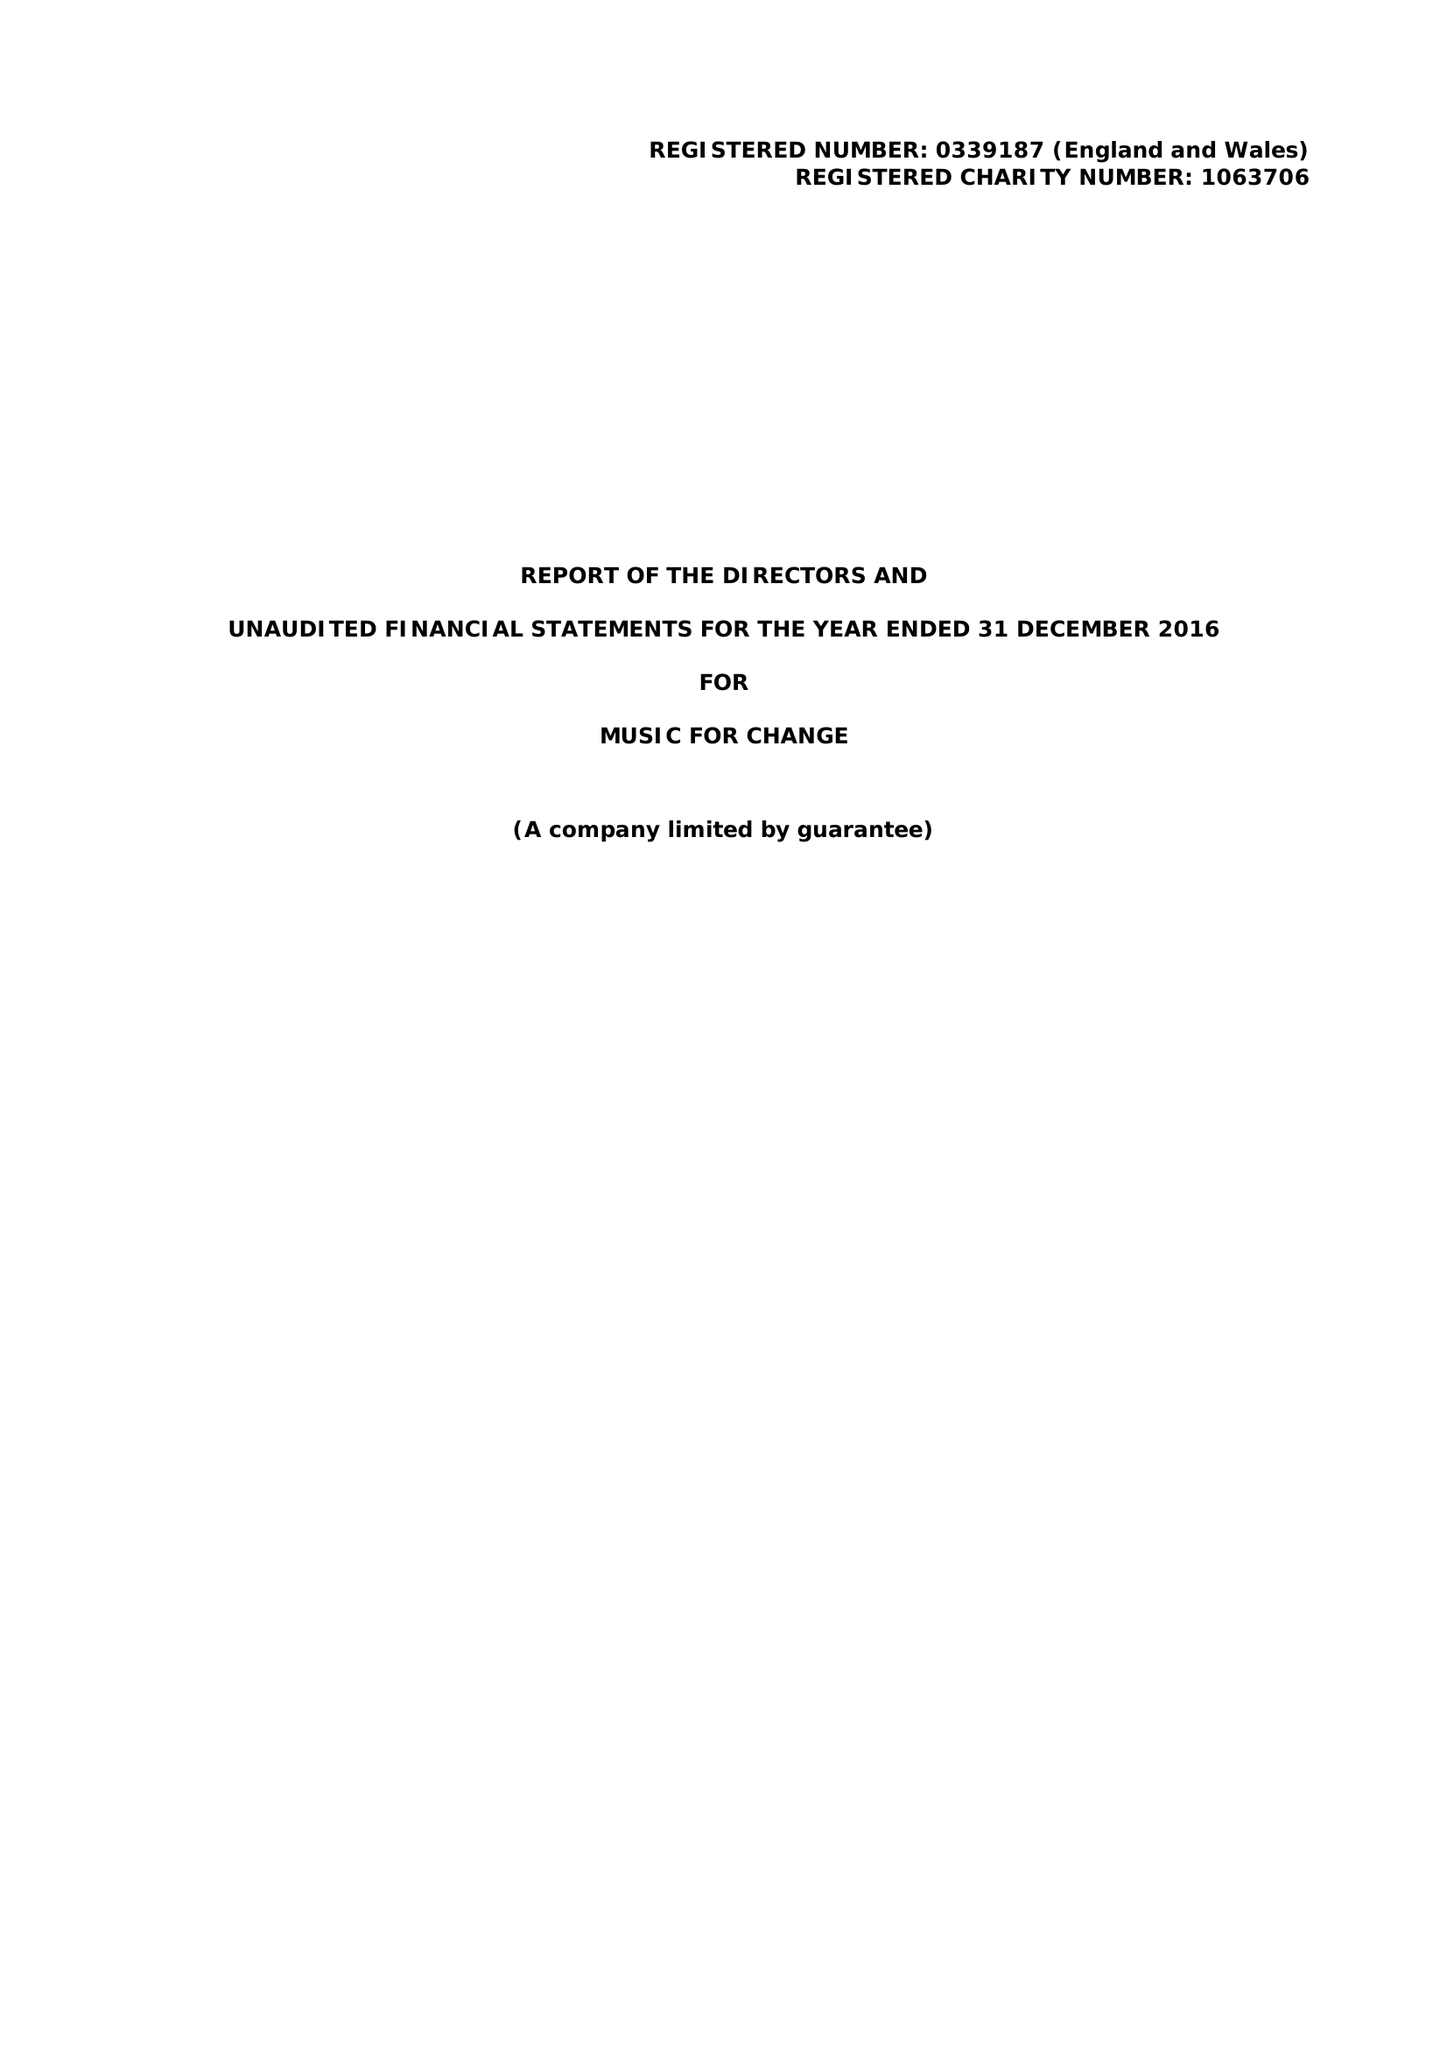What is the value for the income_annually_in_british_pounds?
Answer the question using a single word or phrase. 145474.00 